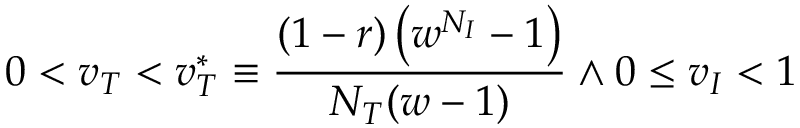<formula> <loc_0><loc_0><loc_500><loc_500>0 < v _ { T } < v _ { T } ^ { * } \equiv \frac { ( 1 - r ) \left ( w ^ { N _ { I } } - 1 \right ) } { N _ { T } ( w - 1 ) } \land 0 \leq v _ { I } < 1</formula> 